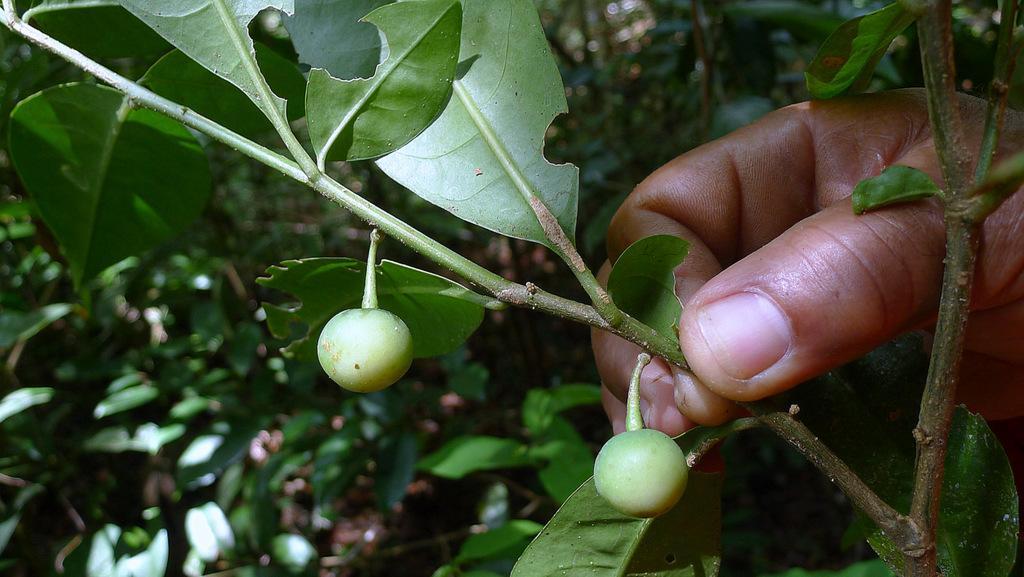Please provide a concise description of this image. In this picture we can see a person's hand and the person is holding a branch. To the branch there are leaves and those are looking like vegetables. Behind the hand, there are plants. 